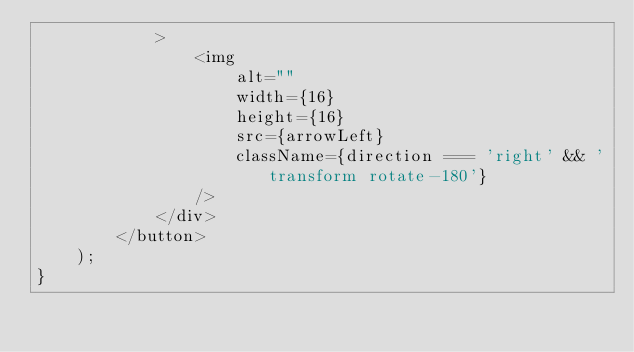<code> <loc_0><loc_0><loc_500><loc_500><_JavaScript_>            >
                <img
                    alt=""
                    width={16}
                    height={16}
                    src={arrowLeft}
                    className={direction === 'right' && 'transform rotate-180'}
                />
            </div>
        </button>
    );
}
</code> 